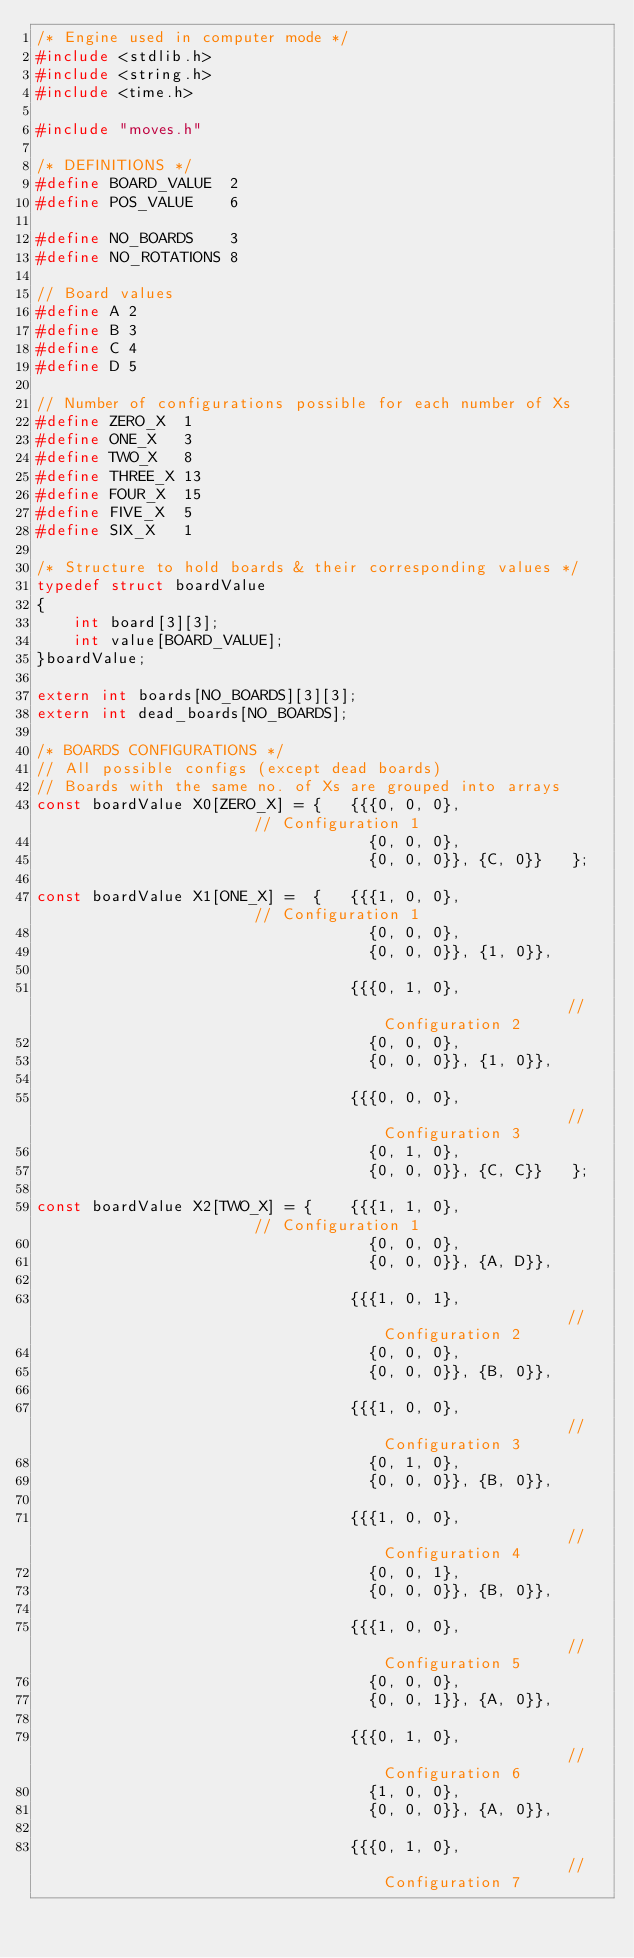Convert code to text. <code><loc_0><loc_0><loc_500><loc_500><_C_>/* Engine used in computer mode */
#include <stdlib.h>
#include <string.h>
#include <time.h>

#include "moves.h" 

/* DEFINITIONS */
#define BOARD_VALUE  2
#define POS_VALUE    6

#define NO_BOARDS    3
#define NO_ROTATIONS 8

// Board values
#define A 2
#define B 3
#define C 4
#define D 5

// Number of configurations possible for each number of Xs
#define ZERO_X  1
#define ONE_X   3 
#define TWO_X   8 
#define THREE_X 13
#define FOUR_X  15 
#define FIVE_X  5
#define SIX_X   1

/* Structure to hold boards & their corresponding values */
typedef struct boardValue
{
    int board[3][3];
    int value[BOARD_VALUE];
}boardValue;

extern int boards[NO_BOARDS][3][3];
extern int dead_boards[NO_BOARDS];

/* BOARDS CONFIGURATIONS */
// All possible configs (except dead boards)
// Boards with the same no. of Xs are grouped into arrays
const boardValue X0[ZERO_X] = {   {{{0, 0, 0},                     // Configuration 1
                                    {0, 0, 0},
                                    {0, 0, 0}}, {C, 0}}   };

const boardValue X1[ONE_X] =  {   {{{1, 0, 0},                     // Configuration 1
                                    {0, 0, 0},
                                    {0, 0, 0}}, {1, 0}},

                                  {{{0, 1, 0},                     // Configuration 2
                                    {0, 0, 0},
                                    {0, 0, 0}}, {1, 0}},

                                  {{{0, 0, 0},                     // Configuration 3
                                    {0, 1, 0},
                                    {0, 0, 0}}, {C, C}}   };

const boardValue X2[TWO_X] = {    {{{1, 1, 0},                     // Configuration 1
                                    {0, 0, 0},
                                    {0, 0, 0}}, {A, D}},

                                  {{{1, 0, 1},                     // Configuration 2
                                    {0, 0, 0},
                                    {0, 0, 0}}, {B, 0}},

                                  {{{1, 0, 0},                     // Configuration 3
                                    {0, 1, 0},
                                    {0, 0, 0}}, {B, 0}},

                                  {{{1, 0, 0},                     // Configuration 4
                                    {0, 0, 1},
                                    {0, 0, 0}}, {B, 0}},

                                  {{{1, 0, 0},                     // Configuration 5
                                    {0, 0, 0},
                                    {0, 0, 1}}, {A, 0}},

                                  {{{0, 1, 0},                     // Configuration 6
                                    {1, 0, 0},
                                    {0, 0, 0}}, {A, 0}},

                                  {{{0, 1, 0},                     // Configuration 7</code> 